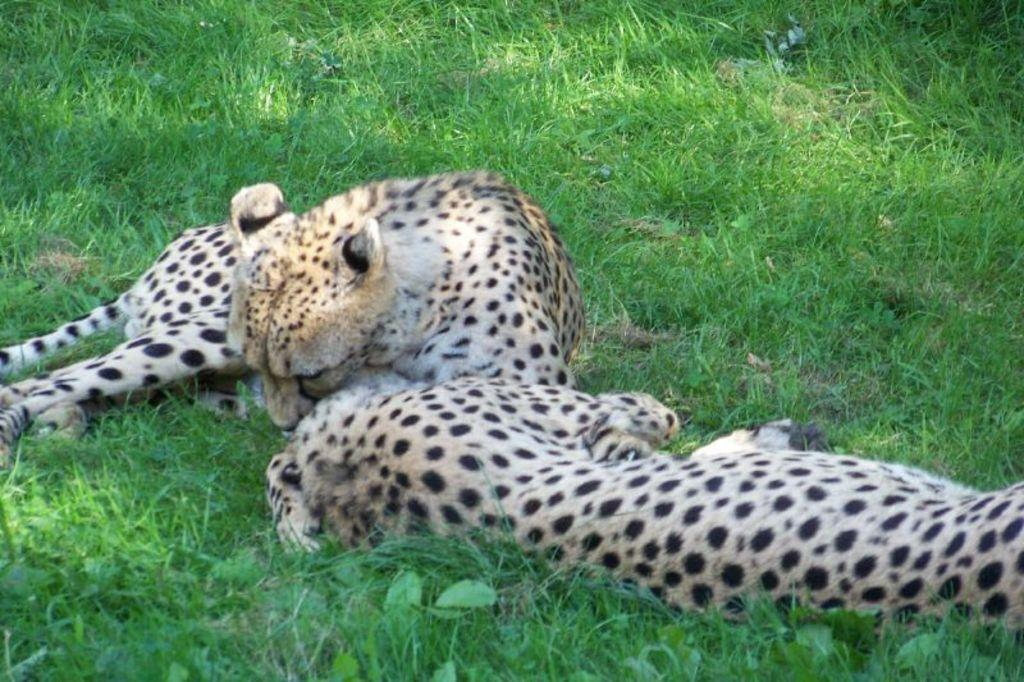What animals are present in the image? There are two cheetahs in the image. What is the cheetahs' position in the image? The cheetahs are laying on the grassland. What type of clam can be seen in the image? There are no clams present in the image; it features two cheetahs laying on the grassland. How many pickles are visible in the image? There are no pickles present in the image. 